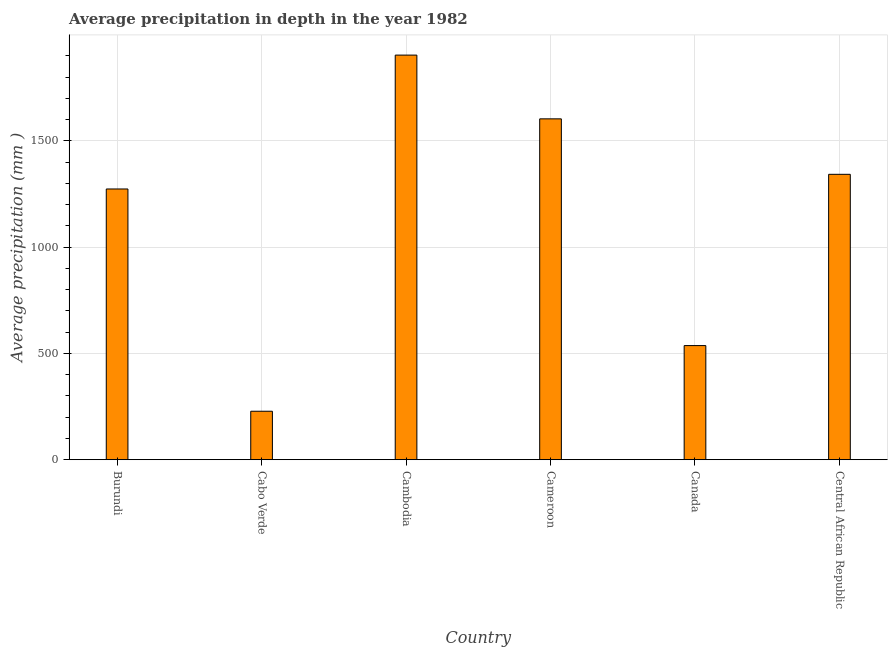Does the graph contain any zero values?
Ensure brevity in your answer.  No. Does the graph contain grids?
Ensure brevity in your answer.  Yes. What is the title of the graph?
Provide a short and direct response. Average precipitation in depth in the year 1982. What is the label or title of the X-axis?
Ensure brevity in your answer.  Country. What is the label or title of the Y-axis?
Offer a very short reply. Average precipitation (mm ). What is the average precipitation in depth in Cambodia?
Give a very brief answer. 1904. Across all countries, what is the maximum average precipitation in depth?
Offer a very short reply. 1904. Across all countries, what is the minimum average precipitation in depth?
Provide a short and direct response. 228. In which country was the average precipitation in depth maximum?
Ensure brevity in your answer.  Cambodia. In which country was the average precipitation in depth minimum?
Ensure brevity in your answer.  Cabo Verde. What is the sum of the average precipitation in depth?
Offer a very short reply. 6890. What is the difference between the average precipitation in depth in Burundi and Cameroon?
Provide a short and direct response. -330. What is the average average precipitation in depth per country?
Your response must be concise. 1148. What is the median average precipitation in depth?
Ensure brevity in your answer.  1308.5. What is the ratio of the average precipitation in depth in Cameroon to that in Central African Republic?
Provide a short and direct response. 1.19. Is the average precipitation in depth in Cambodia less than that in Cameroon?
Make the answer very short. No. What is the difference between the highest and the second highest average precipitation in depth?
Your response must be concise. 300. Is the sum of the average precipitation in depth in Cambodia and Central African Republic greater than the maximum average precipitation in depth across all countries?
Your response must be concise. Yes. What is the difference between the highest and the lowest average precipitation in depth?
Keep it short and to the point. 1676. How many bars are there?
Offer a very short reply. 6. How many countries are there in the graph?
Provide a succinct answer. 6. What is the difference between two consecutive major ticks on the Y-axis?
Offer a terse response. 500. What is the Average precipitation (mm ) of Burundi?
Make the answer very short. 1274. What is the Average precipitation (mm ) of Cabo Verde?
Provide a succinct answer. 228. What is the Average precipitation (mm ) of Cambodia?
Provide a short and direct response. 1904. What is the Average precipitation (mm ) in Cameroon?
Ensure brevity in your answer.  1604. What is the Average precipitation (mm ) of Canada?
Give a very brief answer. 537. What is the Average precipitation (mm ) of Central African Republic?
Make the answer very short. 1343. What is the difference between the Average precipitation (mm ) in Burundi and Cabo Verde?
Make the answer very short. 1046. What is the difference between the Average precipitation (mm ) in Burundi and Cambodia?
Provide a succinct answer. -630. What is the difference between the Average precipitation (mm ) in Burundi and Cameroon?
Give a very brief answer. -330. What is the difference between the Average precipitation (mm ) in Burundi and Canada?
Provide a succinct answer. 737. What is the difference between the Average precipitation (mm ) in Burundi and Central African Republic?
Provide a short and direct response. -69. What is the difference between the Average precipitation (mm ) in Cabo Verde and Cambodia?
Keep it short and to the point. -1676. What is the difference between the Average precipitation (mm ) in Cabo Verde and Cameroon?
Provide a succinct answer. -1376. What is the difference between the Average precipitation (mm ) in Cabo Verde and Canada?
Offer a terse response. -309. What is the difference between the Average precipitation (mm ) in Cabo Verde and Central African Republic?
Your response must be concise. -1115. What is the difference between the Average precipitation (mm ) in Cambodia and Cameroon?
Your answer should be compact. 300. What is the difference between the Average precipitation (mm ) in Cambodia and Canada?
Keep it short and to the point. 1367. What is the difference between the Average precipitation (mm ) in Cambodia and Central African Republic?
Give a very brief answer. 561. What is the difference between the Average precipitation (mm ) in Cameroon and Canada?
Provide a succinct answer. 1067. What is the difference between the Average precipitation (mm ) in Cameroon and Central African Republic?
Provide a succinct answer. 261. What is the difference between the Average precipitation (mm ) in Canada and Central African Republic?
Ensure brevity in your answer.  -806. What is the ratio of the Average precipitation (mm ) in Burundi to that in Cabo Verde?
Your answer should be compact. 5.59. What is the ratio of the Average precipitation (mm ) in Burundi to that in Cambodia?
Provide a short and direct response. 0.67. What is the ratio of the Average precipitation (mm ) in Burundi to that in Cameroon?
Offer a terse response. 0.79. What is the ratio of the Average precipitation (mm ) in Burundi to that in Canada?
Give a very brief answer. 2.37. What is the ratio of the Average precipitation (mm ) in Burundi to that in Central African Republic?
Ensure brevity in your answer.  0.95. What is the ratio of the Average precipitation (mm ) in Cabo Verde to that in Cambodia?
Ensure brevity in your answer.  0.12. What is the ratio of the Average precipitation (mm ) in Cabo Verde to that in Cameroon?
Your answer should be very brief. 0.14. What is the ratio of the Average precipitation (mm ) in Cabo Verde to that in Canada?
Your answer should be very brief. 0.42. What is the ratio of the Average precipitation (mm ) in Cabo Verde to that in Central African Republic?
Your answer should be compact. 0.17. What is the ratio of the Average precipitation (mm ) in Cambodia to that in Cameroon?
Give a very brief answer. 1.19. What is the ratio of the Average precipitation (mm ) in Cambodia to that in Canada?
Your answer should be very brief. 3.55. What is the ratio of the Average precipitation (mm ) in Cambodia to that in Central African Republic?
Offer a very short reply. 1.42. What is the ratio of the Average precipitation (mm ) in Cameroon to that in Canada?
Provide a short and direct response. 2.99. What is the ratio of the Average precipitation (mm ) in Cameroon to that in Central African Republic?
Make the answer very short. 1.19. 